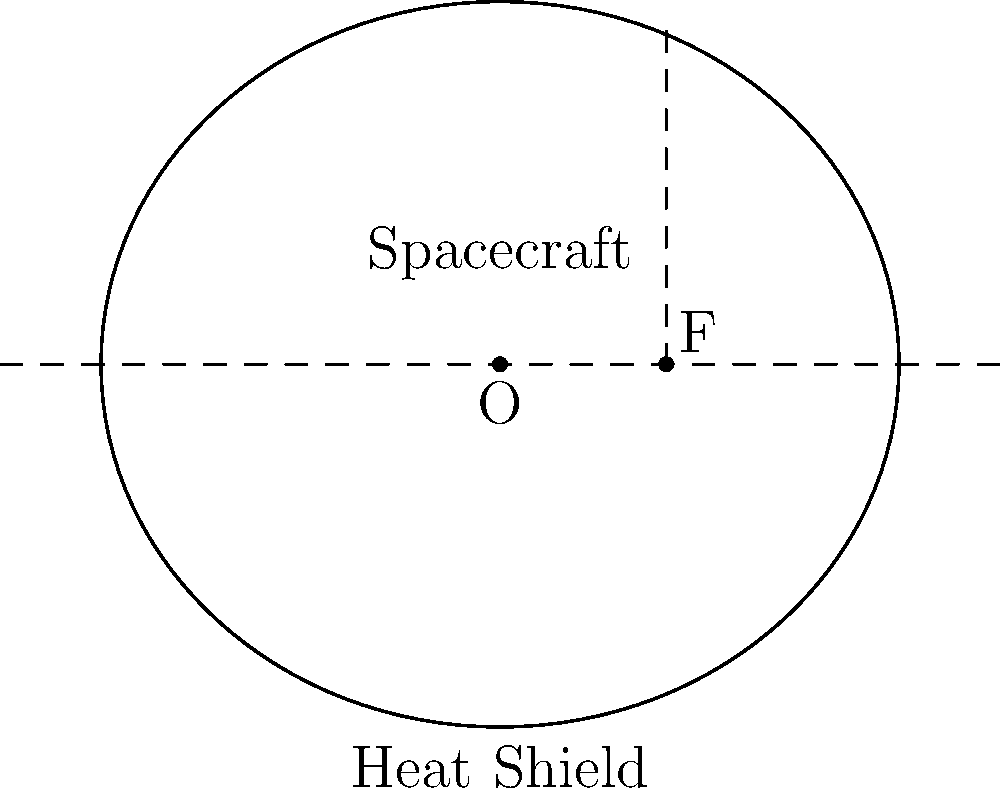As a pioneering astronaut, you're tasked with optimizing the shape of a heat shield for atmospheric reentry. The engineers propose using an elliptical shape for the heat shield, with the spacecraft positioned at one of the foci. If the semi-major axis of the ellipse is 1.2 units and the distance from the center to a focus is 0.5 units, what is the eccentricity of the elliptical heat shield? How does this shape contribute to the effectiveness of the heat shield during reentry? Let's approach this step-by-step:

1) For an ellipse, we know:
   - Semi-major axis $a = 1.2$ units
   - Distance from center to focus $c = 0.5$ units

2) The eccentricity $e$ of an ellipse is given by the formula:

   $$e = \frac{c}{a}$$

3) Substituting our known values:

   $$e = \frac{0.5}{1.2}$$

4) Simplifying:

   $$e = \frac{5}{12} \approx 0.4167$$

5) The effectiveness of this shape for a heat shield:
   - The elliptical shape helps distribute heat more evenly across the surface.
   - With the spacecraft at one focus, the heat shield provides maximum protection at the point of highest heat generation.
   - The eccentricity of about 0.4167 indicates a moderately elongated ellipse, which:
     a) Provides a good balance between heat distribution and directional protection.
     b) Allows for effective heat dissipation while maintaining structural integrity.
   - This shape also helps in maintaining stability during reentry due to its symmetrical nature.
Answer: Eccentricity $\approx 0.4167$; elliptical shape optimizes heat distribution and directional protection. 